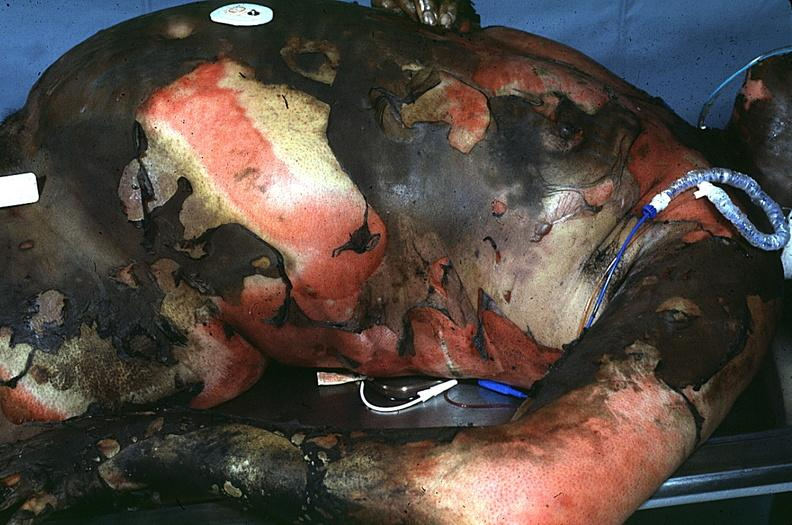does abruption show thermal burn?
Answer the question using a single word or phrase. No 